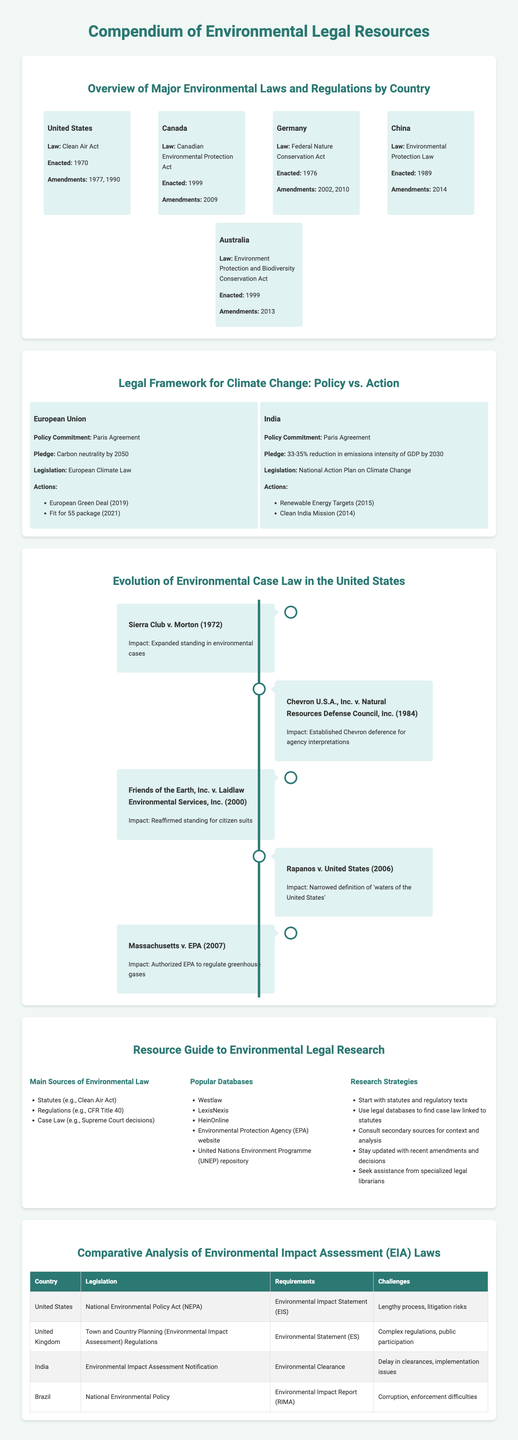What law was enacted in 1970 in the United States? The Clean Air Act was enacted in the United States in 1970 as mentioned in the document.
Answer: Clean Air Act When was the European Climate Law established? The document outlines that the European Climate Law is part of the legal framework for climate change and was established in 2021.
Answer: 2021 Which country has the Environmental Impact Assessment Notification? The document lists India as having the Environmental Impact Assessment Notification as part of their legislation.
Answer: India What amendment year is listed for the Canadian Environmental Protection Act? The infographic provides information that the amendment for the Canadian Environmental Protection Act occurred in 2009.
Answer: 2009 Which landmark case expanded standing in environmental cases? The Sierra Club v. Morton case is noted in the timeline as having expanded standing for environmental cases.
Answer: Sierra Club v. Morton What is one challenge noted for Brazil's Environmental Impact Report? The challenges faced by Brazil are mentioned, with corruption being one of them.
Answer: Corruption What was the pledge made by India according to the Paris Agreement? The document states that India's pledge is to achieve a 33-35% reduction in emissions intensity of GDP by 2030.
Answer: 33-35% reduction What is a primary strategy for effective environmental legal research? The document lists starting with statutes and regulatory texts as a primary strategy for legal research.
Answer: Start with statutes and regulatory texts Which law helps to assess environmental impacts in the United Kingdom? The Town and Country Planning (Environmental Impact Assessment) Regulations is the legislation for assessing environmental impacts in the UK.
Answer: Town and Country Planning (Environmental Impact Assessment) Regulations 